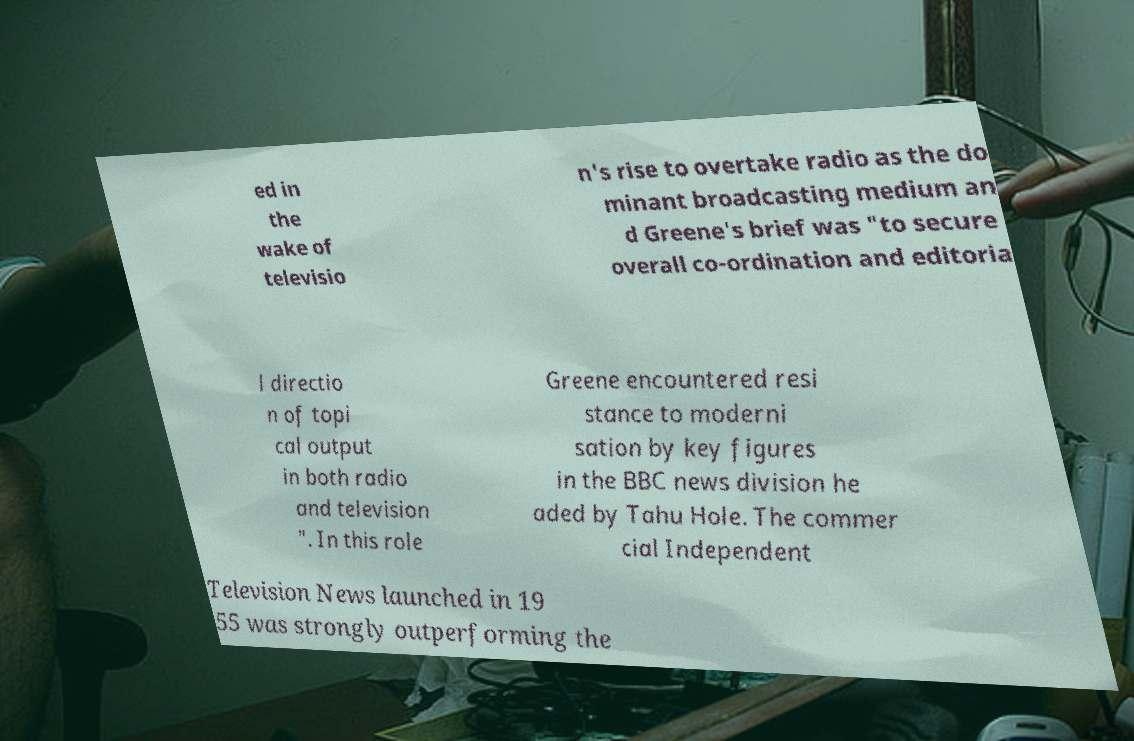Could you extract and type out the text from this image? ed in the wake of televisio n's rise to overtake radio as the do minant broadcasting medium an d Greene's brief was "to secure overall co-ordination and editoria l directio n of topi cal output in both radio and television ". In this role Greene encountered resi stance to moderni sation by key figures in the BBC news division he aded by Tahu Hole. The commer cial Independent Television News launched in 19 55 was strongly outperforming the 